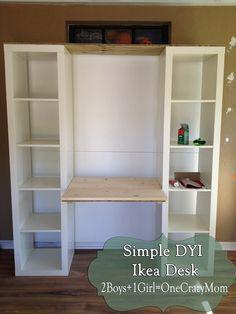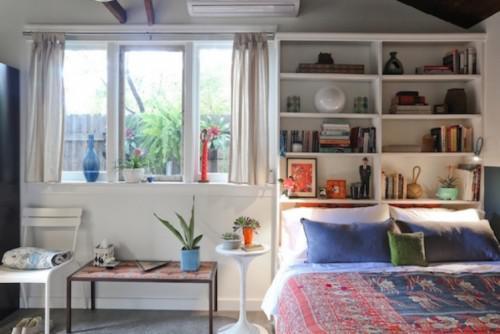The first image is the image on the left, the second image is the image on the right. Analyze the images presented: Is the assertion "Three chairs with wheels are in front of a desk in one of the pictures." valid? Answer yes or no. No. The first image is the image on the left, the second image is the image on the right. For the images displayed, is the sentence "One of the images features a desk with three chairs." factually correct? Answer yes or no. No. 